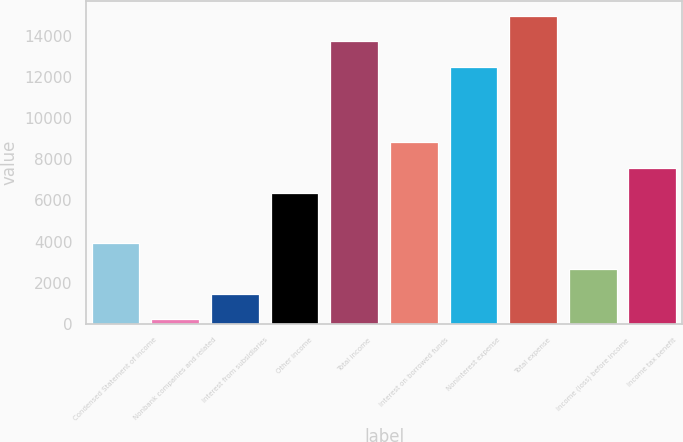Convert chart to OTSL. <chart><loc_0><loc_0><loc_500><loc_500><bar_chart><fcel>Condensed Statement of Income<fcel>Nonbank companies and related<fcel>Interest from subsidiaries<fcel>Other income<fcel>Total income<fcel>Interest on borrowed funds<fcel>Noninterest expense<fcel>Total expense<fcel>Income (loss) before income<fcel>Income tax benefit<nl><fcel>3912.4<fcel>226<fcel>1454.8<fcel>6370<fcel>13742.8<fcel>8827.6<fcel>12514<fcel>14971.6<fcel>2683.6<fcel>7598.8<nl></chart> 